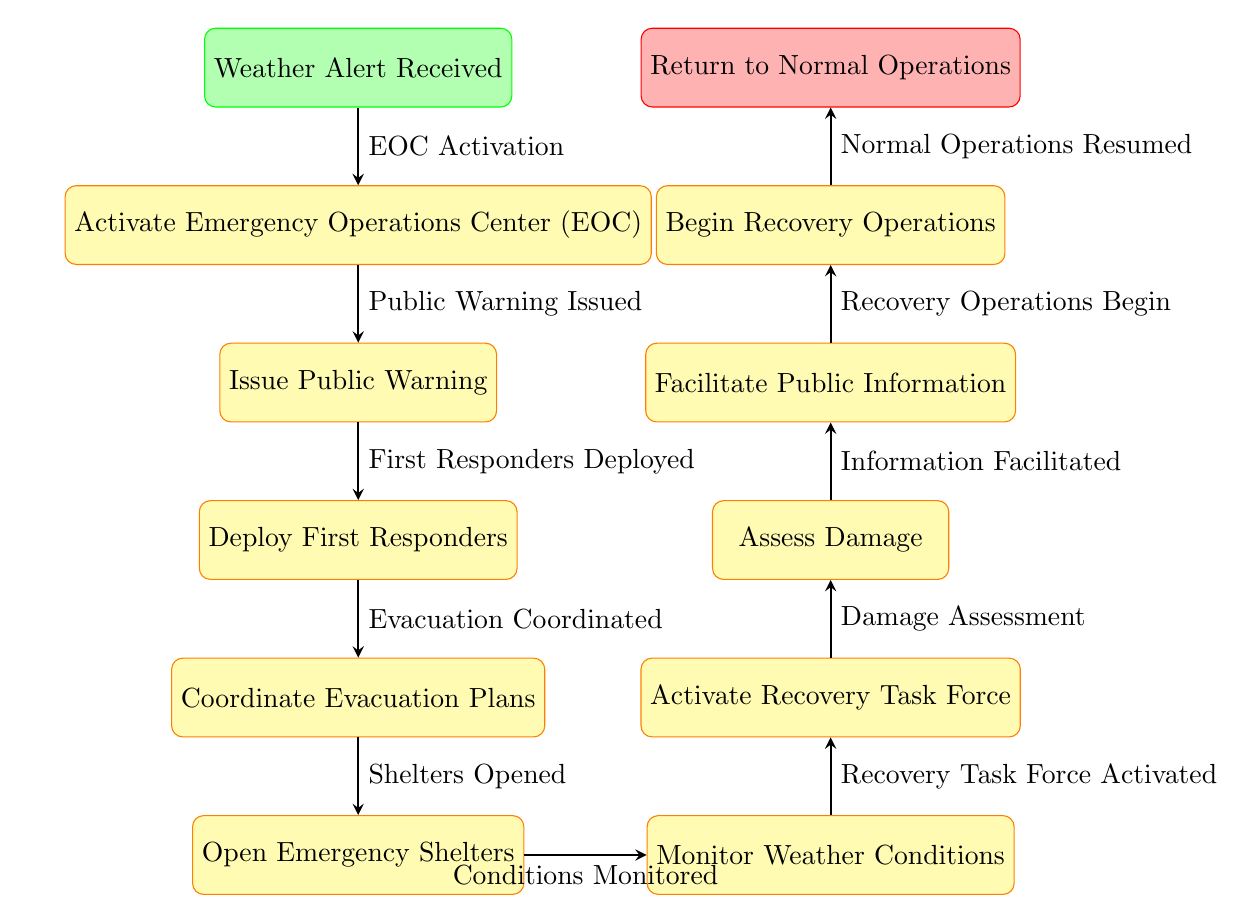What is the first step after a weather alert is received? The diagram starts with the node labeled "Weather Alert Received." The first process following this step is "Activate Emergency Operations Center (EOC)." Therefore, the next step is specifically what follows this alert.
Answer: Activate Emergency Operations Center (EOC) How many major steps are outlined in the flowchart? The flowchart consists of key steps starting from "Weather Alert Received" through to "Return to Normal Operations." Counting each of these steps gives a total of eleven distinct steps.
Answer: 11 What action follows after the public warning is issued? Referring to the flowchart, after the "Issue Public Warning" step, the flow leads directly to the "Deploy First Responders" node. This shows the direct sequence of actions taken after the public has been warned.
Answer: Deploy First Responders What step occurs immediately before the shelters are opened? The process leading to "Open Emergency Shelters" starts at the "Coordinate Evacuation Plans" step. This logic allows us to derive that "Coordinate Evacuation Plans" is the immediate predecessor in the sequence.
Answer: Coordinate Evacuation Plans What do the arrows in the diagram signify? In the flowchart, arrows demonstrate the progression of actions from one step to the next, effectively illustrating the relationships and sequence of steps in the severe weather response process. They indicate the direction of the workflow.
Answer: Workflow direction Which step involves assessing damage? The flowchart indicates that the "Assess Damage" node comes after "Activate Recovery Task Force" and before "Facilitate Public Information." Therefore, it is identified specifically in that part of the response sequence.
Answer: Assess Damage What happens after the recovery operations begin? According to the flowchart, after the "Begin Recovery Operations" step is completed, it leads directly to "Return to Normal Operations," marking the conclusion of the emergency response.
Answer: Return to Normal Operations How many steps are there between monitoring weather conditions and beginning recovery operations? From the "Monitor Weather Conditions" node to "Begin Recovery Operations," there are three intervening steps: "Activate Recovery Task Force," "Assess Damage," and "Facilitate Public Information." Thus, we count these steps for a total of three transitionary processes.
Answer: 3 